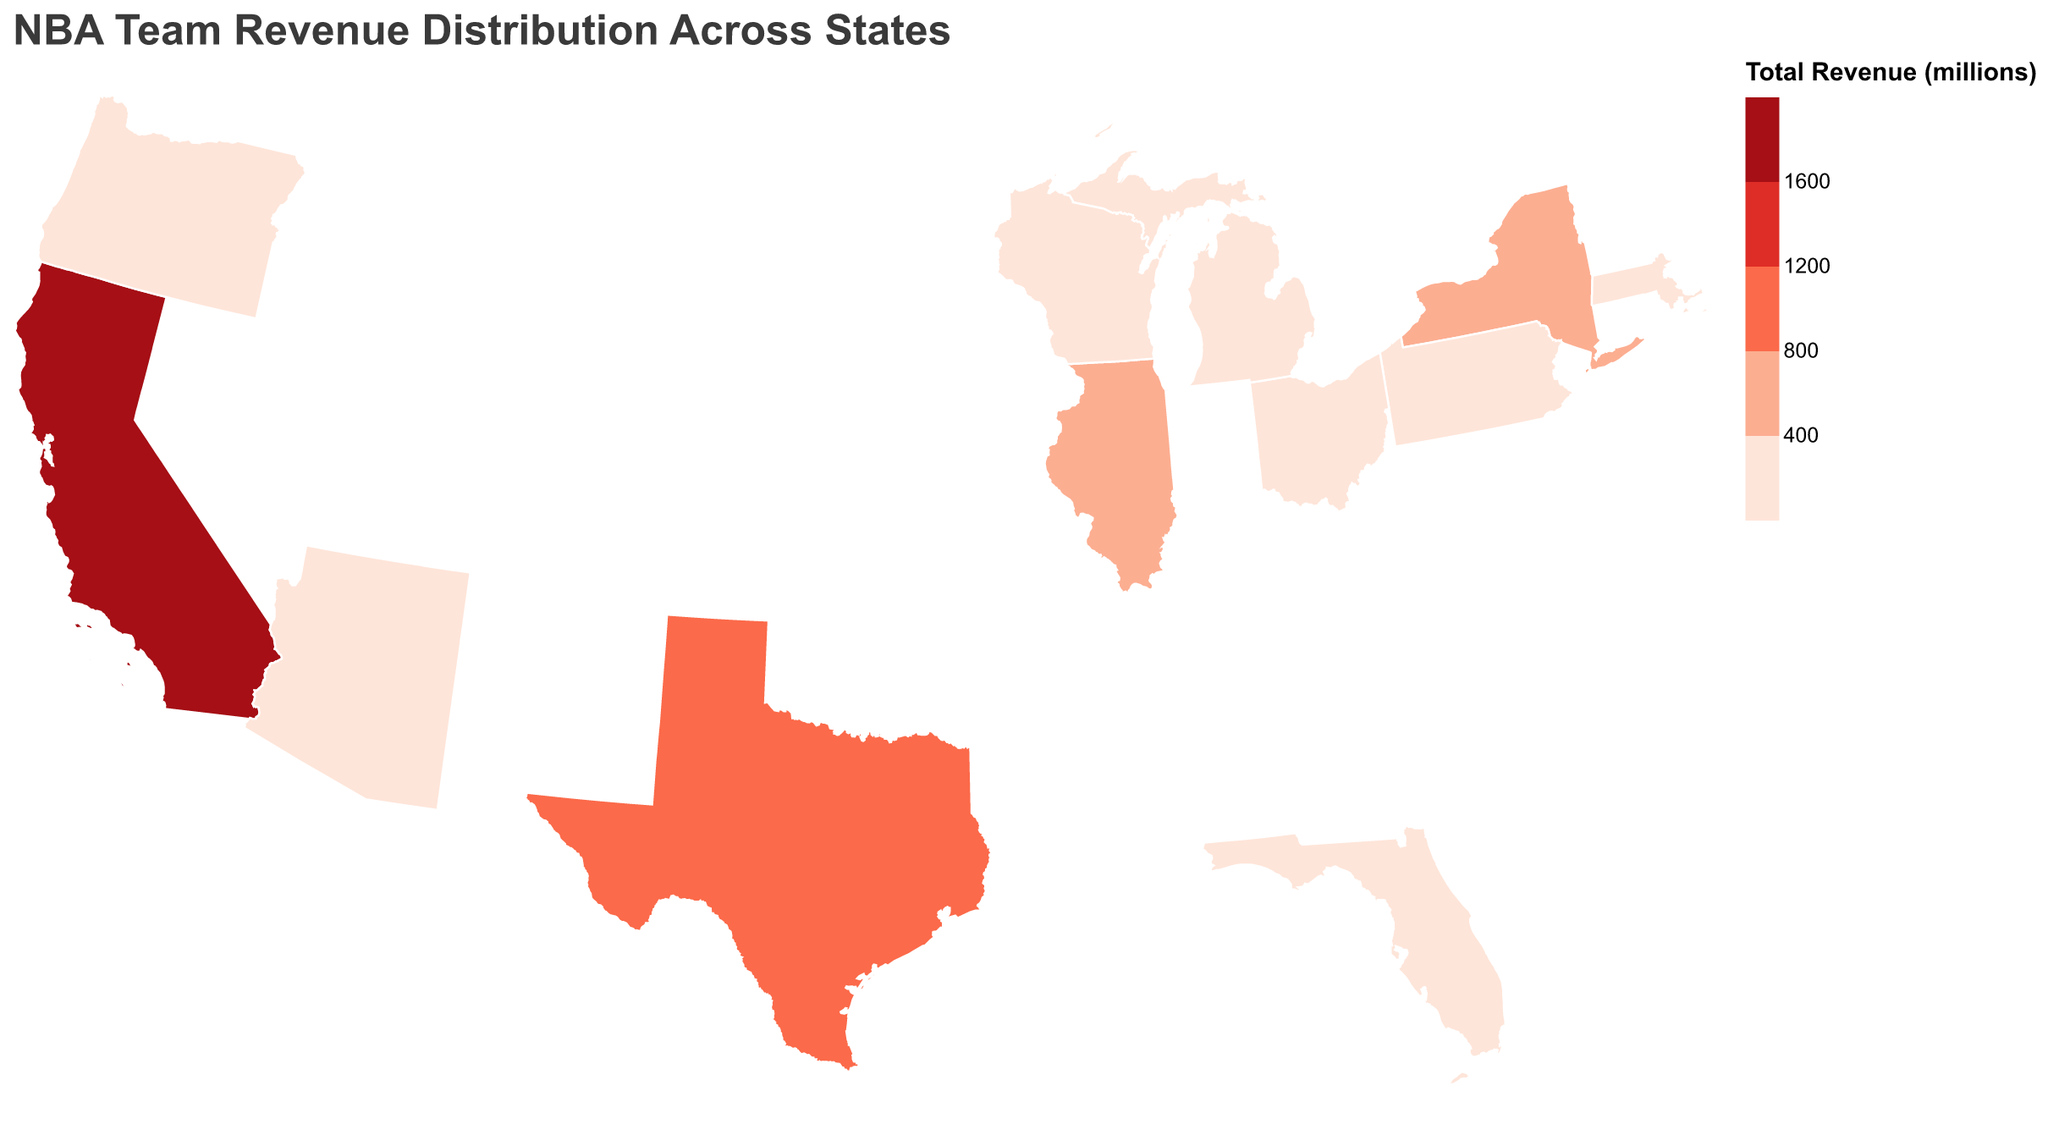Which state has the highest total revenue from NBA teams? Look for the state with the darkest color in the plot. According to the color legend, darker colors represent higher revenues. California is the state with the darkest color.
Answer: California What is the total revenue for NBA teams in Texas? Use the tooltip for Texas to find the total revenue figure. According to the plot, Texas has a total revenue of 879 million dollars.
Answer: 879 How many teams are there in California, and what are their combined revenue? The tooltip for California will show the total revenue, and the presence of three teams (Golden State Warriors, Los Angeles Lakers, and Los Angeles Clippers) indicates three teams. Their combined revenue of 1,759 million dollars comes from summing their individual revenues (696 + 661 + 402).
Answer: 3 teams, 1,759 million dollars Which team ranks second in revenue in California? Within California, the team with the second highest revenue is the Los Angeles Lakers with a revenue of 661 million dollars, just after the Golden State Warriors.
Answer: Los Angeles Lakers How does Florida's total revenue from NBA teams compare to that of Illinois? Comparing the tooltip values, Florida's total revenue is 373 million dollars while Illinois', where the Chicago Bulls are located, is 410 million dollars. Illinois has a higher total revenue than Florida.
Answer: Illinois has higher total revenue Are there any states with exactly two NBA teams listed for revenues? By examining the plot and checking each state's total revenue, we see that Texas is the only state with two teams (Dallas Mavericks and Houston Rockets) shown.
Answer: Texas What is the difference in total revenue between the highest revenue state and the lowest revenue state? The highest revenue state is California (1,759 million dollars), and the lowest is Wisconsin (316 million dollars). The difference is calculated as 1,759 - 316.
Answer: 1,443 million dollars Which states' total revenues fall within the range of 300 to 400 million dollars? By examining the plot and using the color legend, states with revenues in the specified range include Massachusetts (397 million dollars), Florida (373 million dollars), Pennsylvania (360 million dollars), Ohio (355 million dollars), Oregon (349 million dollars), Arizona (334 million dollars), and Michigan (325 million dollars).
Answer: Massachusetts, Florida, Pennsylvania, Ohio, Oregon, Arizona, Michigan 